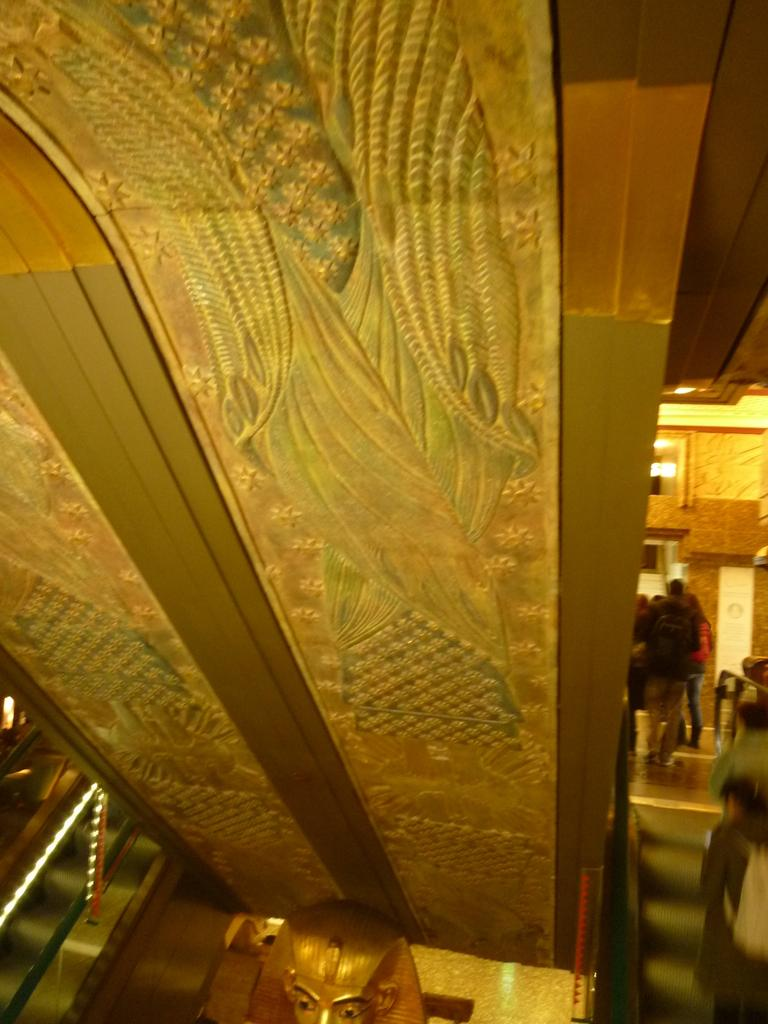What is the main subject in the image? The main subject in the image is a pillar with a design. What is the style or origin of the pillar? The pillar may be an Egyptian sculpture. What is the color of the pillar? The pillar is gold in color. What else can be seen in the image besides the pillar? There are groups of people standing in the image, and there is a wall. What is the average income of the men standing near the pillar in the image? There is no information about the income of the people in the image, nor is there any indication that they are men. 